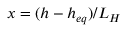Convert formula to latex. <formula><loc_0><loc_0><loc_500><loc_500>x = ( h - h _ { e q } ) / L _ { H }</formula> 